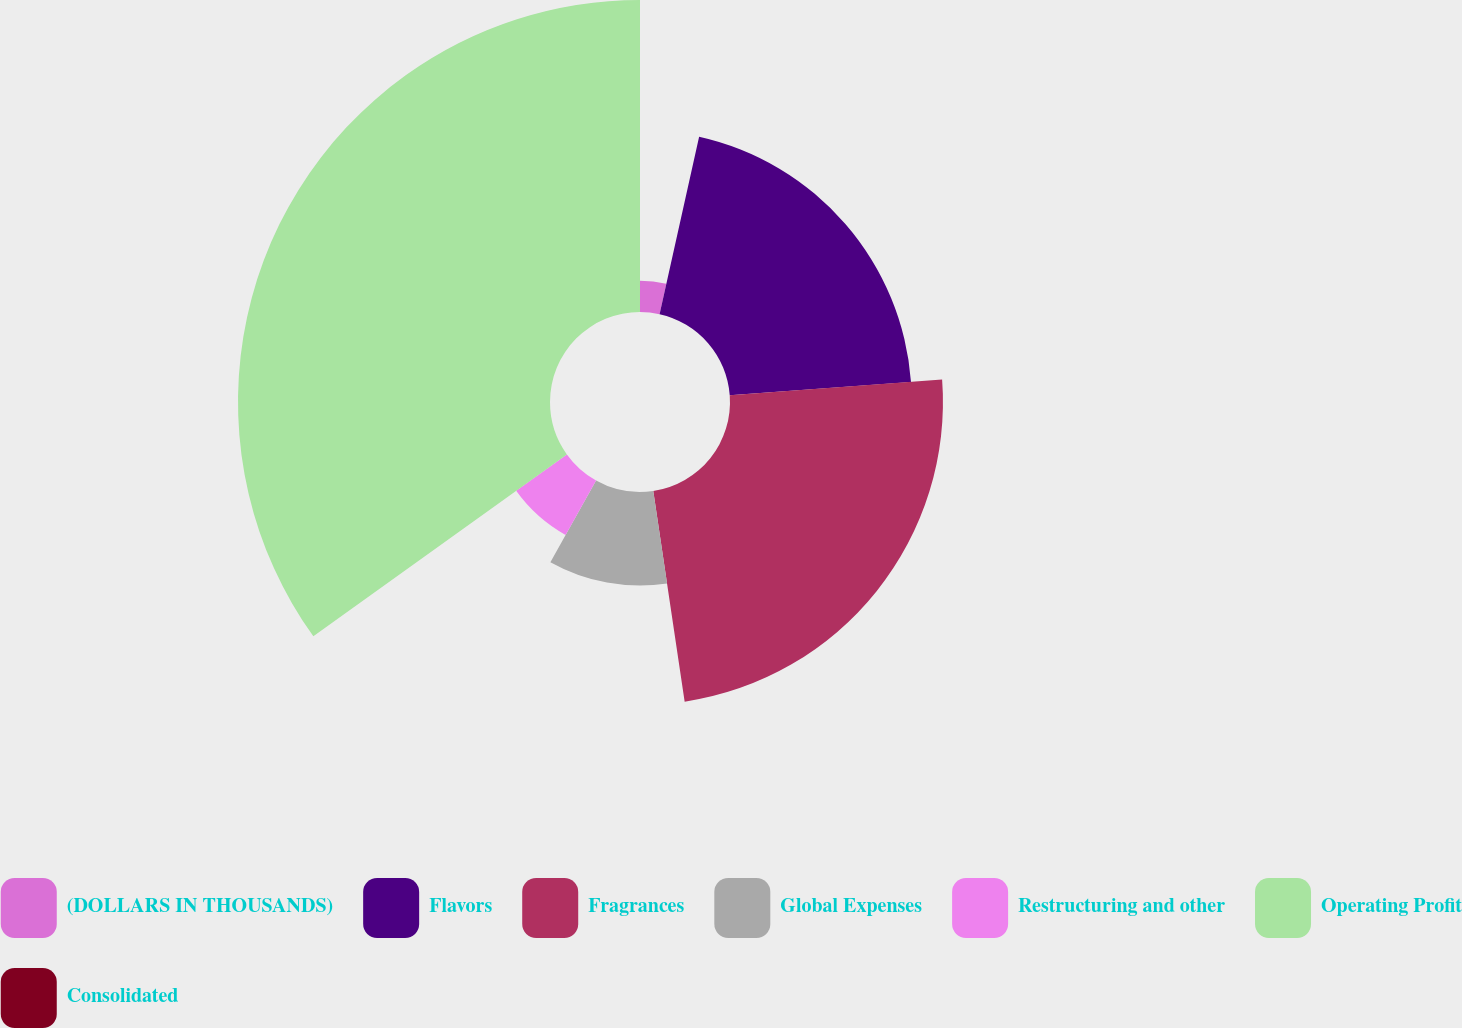Convert chart. <chart><loc_0><loc_0><loc_500><loc_500><pie_chart><fcel>(DOLLARS IN THOUSANDS)<fcel>Flavors<fcel>Fragrances<fcel>Global Expenses<fcel>Restructuring and other<fcel>Operating Profit<fcel>Consolidated<nl><fcel>3.49%<fcel>20.33%<fcel>23.82%<fcel>10.47%<fcel>6.98%<fcel>34.9%<fcel>0.0%<nl></chart> 